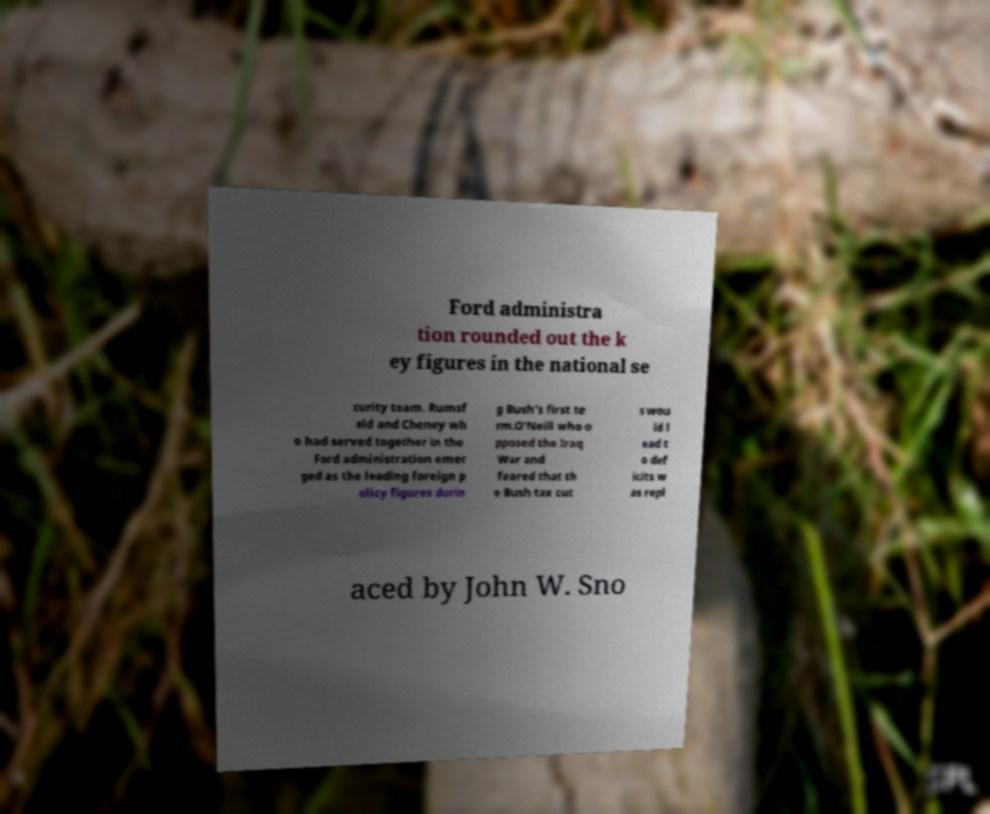Can you read and provide the text displayed in the image?This photo seems to have some interesting text. Can you extract and type it out for me? Ford administra tion rounded out the k ey figures in the national se curity team. Rumsf eld and Cheney wh o had served together in the Ford administration emer ged as the leading foreign p olicy figures durin g Bush's first te rm.O'Neill who o pposed the Iraq War and feared that th e Bush tax cut s wou ld l ead t o def icits w as repl aced by John W. Sno 